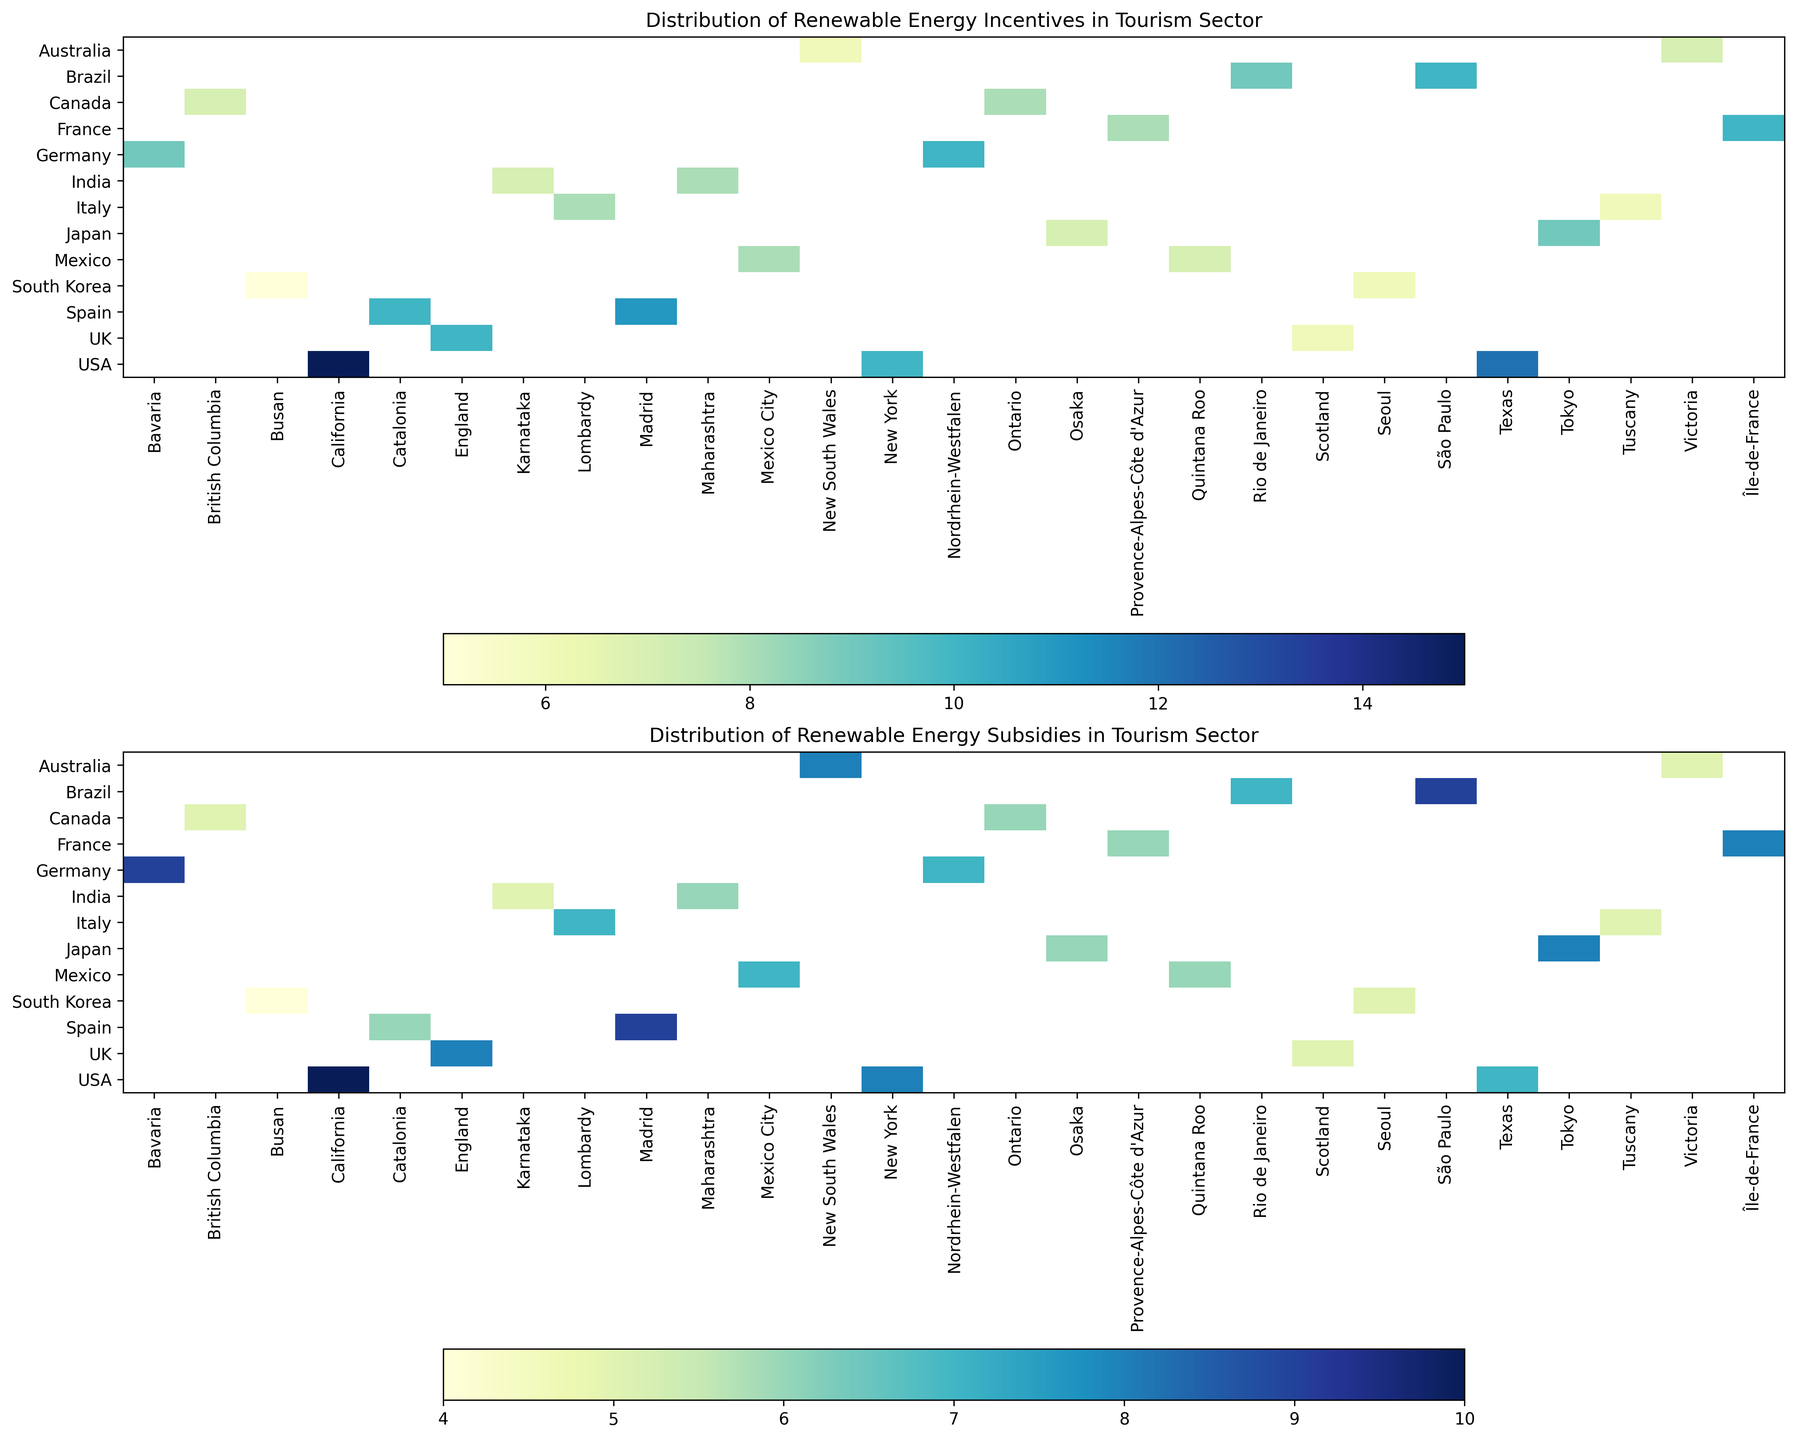Which country has the highest total count of renewable energy incentives for the tourism sector? To find the country with the highest total count, sum the IncentivesCount for all states/regions within each country and compare. The USA has the highest total count with 37 (California: 15, New York: 10, Texas: 12).
Answer: USA Which state/region in the USA has the highest count of subsidies for the tourism sector? Comparing the count of subsidies across each state/region in the USA, California has 10, New York has 8, and Texas has 7, thus California has the highest count.
Answer: California Which country's regions appear to have the most balanced distribution of renewable energy incentives and subsidies counts for the tourism sector? Germany has Bavaria with 9 incentives and 9 subsidies and Nordrhein-Westfalen with 10 incentives and 7 subsidies, showing a balanced distribution compared to other countries.
Answer: Germany Which state/region has the lowest count of renewable energy subsidies for the tourism sector? By checking each state's subsidies count, Busan in South Korea has the lowest, with 4 subsidies.
Answer: Busan How many more incentives are there in New York compared to Osaka? New York has 10 incentives and Osaka has 7. The difference is calculated by subtracting Osaka's count from New York's count (10 - 7 = 3).
Answer: 3 Compare the counts of renewable energy incentives and subsidies in São Paulo. Are they equal, or is one count higher than the other? São Paulo has 10 incentives and 9 subsidies; therefore, the count of incentives is higher by 1.
Answer: Incentives higher Which region in Spain has the highest combined count of renewable energy incentives and subsidies for the tourism sector? In Spain, Madrid has 11 incentives and 9 subsidies, Catalonia has 10 incentives and 6 subsidies. Summing them, Madrid has 20 and Catalonia has 16. Thus, Madrid has the highest combined count.
Answer: Madrid Is the count of renewable energy subsidies in Tokyo higher or lower than that in Seoul? Tokyo has 8 subsidies while Seoul has 5. Therefore, Tokyo's subsidy count is higher.
Answer: Higher How many states/regions have exactly 6 renewable energy incentives for the tourism sector? By checking each state's incentives count, New South Wales, Tuscany, Scotland, and Seoul each have 6 incentives.
Answer: 4 What is the average count of renewable energy subsidies for the tourism sector in the UK? Adding subsidies from England (8) and Scotland (5) gives 13, divided by the number of regions (2), so the average is 6.5.
Answer: 6.5 